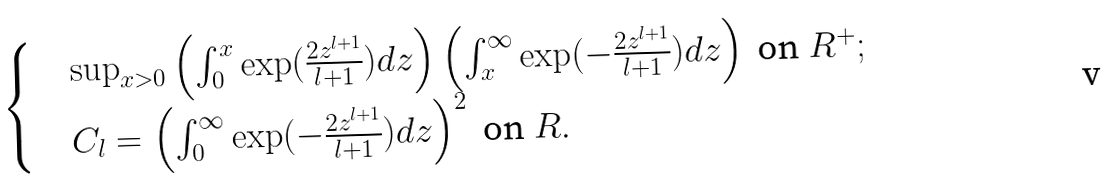<formula> <loc_0><loc_0><loc_500><loc_500>\begin{cases} & \sup _ { x > 0 } \left ( \int _ { 0 } ^ { x } \exp ( \frac { 2 z ^ { l + 1 } } { l + 1 } ) d z \right ) \left ( \int _ { x } ^ { \infty } \exp ( - \frac { 2 z ^ { l + 1 } } { l + 1 } ) d z \right ) \ \text {on} \ R ^ { + } ; \\ & C _ { l } = \left ( \int _ { 0 } ^ { \infty } \exp ( - \frac { 2 z ^ { l + 1 } } { l + 1 } ) d z \right ) ^ { 2 } \ \text {on} \ R . \end{cases}</formula> 